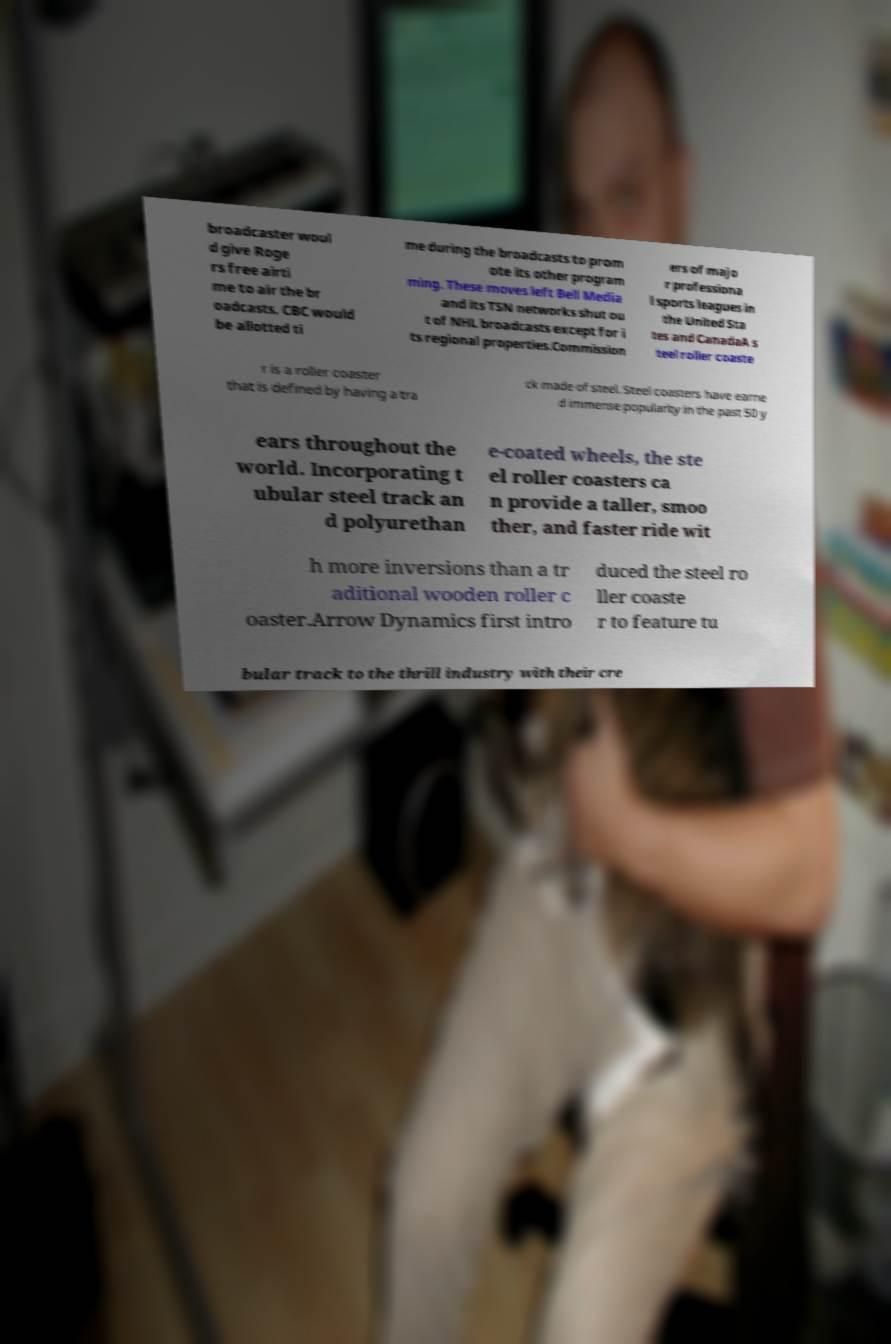Please identify and transcribe the text found in this image. broadcaster woul d give Roge rs free airti me to air the br oadcasts. CBC would be allotted ti me during the broadcasts to prom ote its other program ming. These moves left Bell Media and its TSN networks shut ou t of NHL broadcasts except for i ts regional properties.Commission ers of majo r professiona l sports leagues in the United Sta tes and CanadaA s teel roller coaste r is a roller coaster that is defined by having a tra ck made of steel. Steel coasters have earne d immense popularity in the past 50 y ears throughout the world. Incorporating t ubular steel track an d polyurethan e-coated wheels, the ste el roller coasters ca n provide a taller, smoo ther, and faster ride wit h more inversions than a tr aditional wooden roller c oaster.Arrow Dynamics first intro duced the steel ro ller coaste r to feature tu bular track to the thrill industry with their cre 